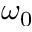Convert formula to latex. <formula><loc_0><loc_0><loc_500><loc_500>\omega _ { 0 }</formula> 